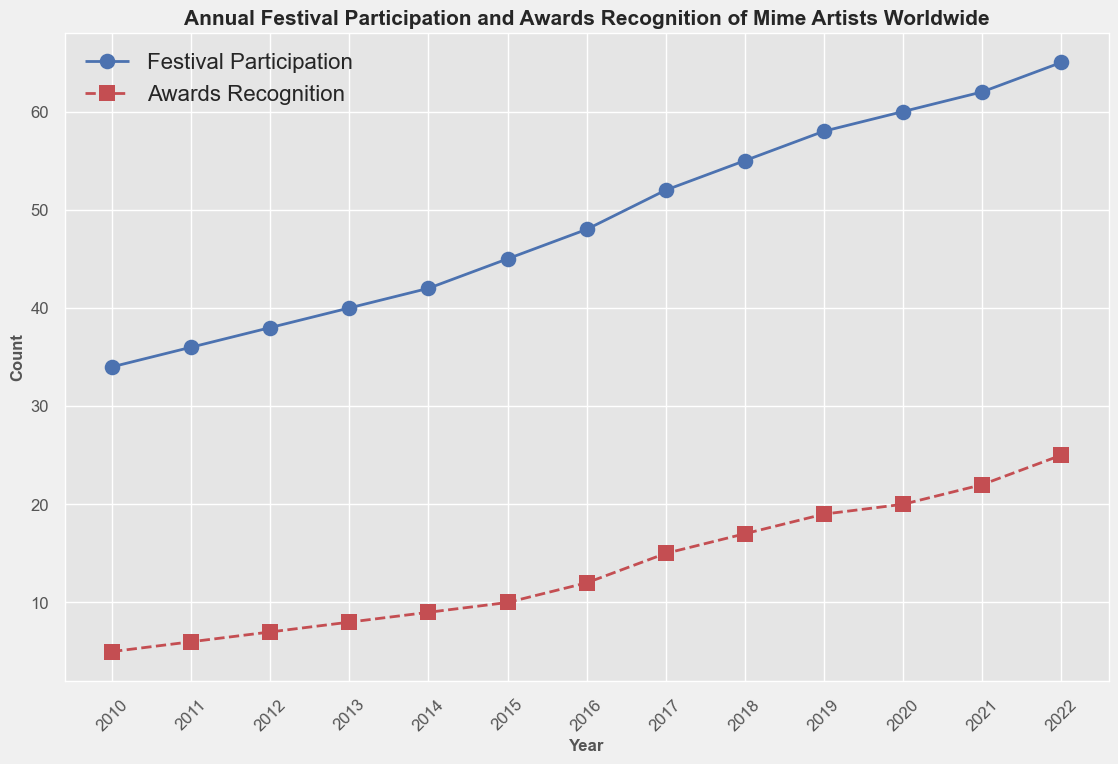What is the highest number of festival participations recorded for mime artists? The highest number of festival participations can be found by identifying the maximum value in the "Festival Participation" line in the chart. Looking at the figure, the peak value is in 2022.
Answer: 65 In which year did mime artists receive 15 awards? By locating the point where the "Awards Recognition" line reaches 15 on the y-axis, we can identify the corresponding year on the x-axis. This is observed in 2017.
Answer: 2017 What are the total festival participations from 2010 to 2015? Sum the "Festival Participation" values for each year from 2010 to 2015: 34 + 36 + 38 + 40 + 42 + 45 = 235.
Answer: 235 How much did awards recognition increase from 2010 to 2022? Identify the values for "Awards Recognition" in 2010 and 2022, then calculate the difference: 25 (2022) - 5 (2010) = 20.
Answer: 20 Did festival participation grow more slowly or more quickly than awards recognition from 2015 to 2020? Compare the increase in values for both "Festival Participation" and "Awards Recognition" from 2015 to 2020. Festival participation grew from 45 to 60, a difference of 15. Awards recognition grew from 10 to 20, a difference of 10. Therefore, festival participation grew more quickly.
Answer: More quickly In which year did mime artists see the largest yearly increase in festival participation? Examine the difference in festival participation between consecutive years. The largest increase occurred between 2016 and 2017: 52 - 48 = 4.
Answer: 2017 Which line in the figure is represented with a dashed red line? Observe the visual attributes of the lines in the chart. The dashed red line corresponds to the "Awards Recognition".
Answer: Awards Recognition What's the difference between festival participation and awards recognition in 2022? Identify the values for both "Festival Participation" and "Awards Recognition" in 2022 and calculate the difference: 65 (Festival Participation) - 25 (Awards Recognition) = 40.
Answer: 40 